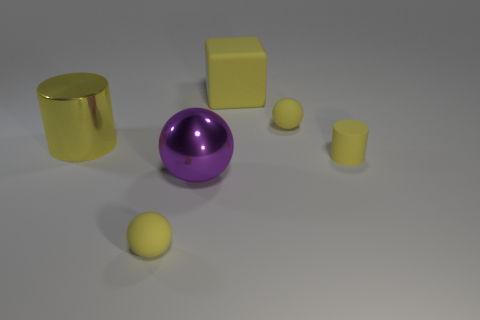Add 1 small things. How many objects exist? 7 Subtract all cubes. How many objects are left? 5 Add 2 big balls. How many big balls exist? 3 Subtract 0 blue cubes. How many objects are left? 6 Subtract all small gray cubes. Subtract all large shiny things. How many objects are left? 4 Add 4 yellow metal objects. How many yellow metal objects are left? 5 